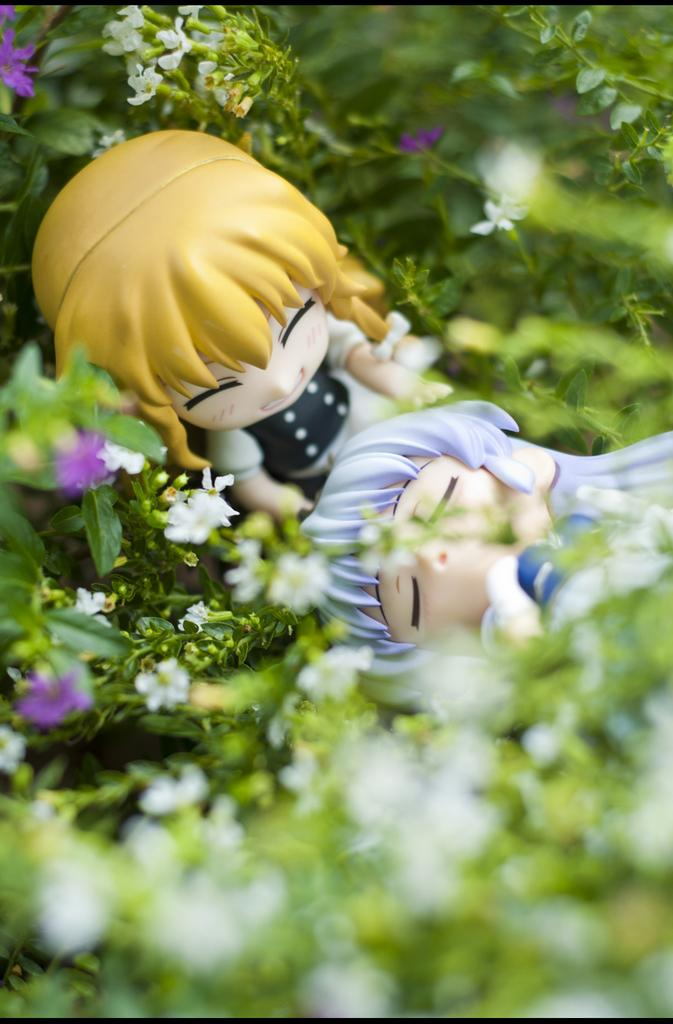What type of objects can be seen in the image? There are toys in the image. What type of natural elements can be seen in the image? There are flowers and plants in the image. What type of kitty can be seen playing with the brake of the train in the image? There is no kitty or train present in the image; it features toys, flowers, and plants. 